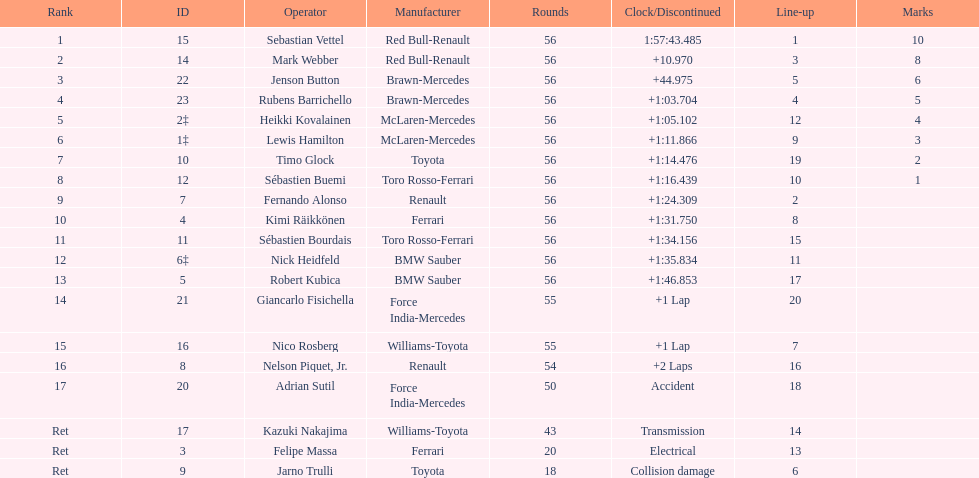What driver was at the end of the list? Jarno Trulli. 